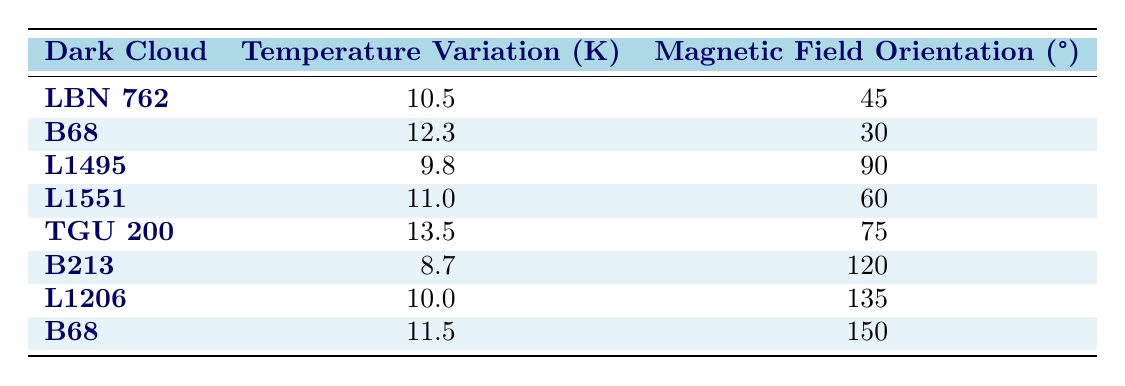What is the temperature variation for dark cloud L1495? Referring to the table, the row corresponding to dark cloud L1495 indicates a temperature variation of 9.8 Kelvin.
Answer: 9.8 Kelvin What is the magnetic field orientation for the dark cloud TGU 200? The table shows that for dark cloud TGU 200, the magnetic field orientation is 75 degrees.
Answer: 75 degrees Which dark cloud has the highest temperature variation? By examining the temperature variations, TGU 200 has the highest value at 13.5 Kelvin, which is greater than all other clouds.
Answer: TGU 200 What is the average temperature variation of all dark clouds listed? To find the average, we first sum all temperature variations: 10.5 + 12.3 + 9.8 + 11.0 + 13.5 + 8.7 + 10.0 + 11.5 =  97.3. Then we divide by the number of dark clouds (8): 97.3 / 8 = 12.2875, rounded to 12.3.
Answer: 12.3 Is the magnetic field orientation for B68 consistent across measurements? There are two entries for dark cloud B68 with different magnetic field orientations (30 degrees and 150 degrees), indicating inconsistency.
Answer: No Which dark cloud has the lowest temperature variation and what is its magnetic field orientation? B213 has the lowest temperature variation at 8.7 Kelvin. The corresponding magnetic field orientation for B213 is 120 degrees.
Answer: B213, 120 degrees Are there any dark clouds that have a magnetic field orientation of 90 degrees or more? The table indicates that L1495 has a magnetic field orientation of 90 degrees, and B213 has 120 degrees, confirming that at least two dark clouds meet this criterion.
Answer: Yes 